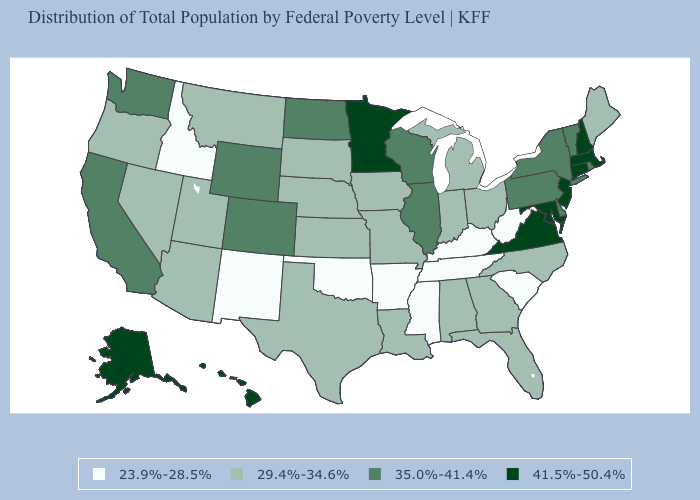Is the legend a continuous bar?
Be succinct. No. Does Massachusetts have a lower value than Arizona?
Concise answer only. No. How many symbols are there in the legend?
Give a very brief answer. 4. Name the states that have a value in the range 35.0%-41.4%?
Quick response, please. California, Colorado, Delaware, Illinois, New York, North Dakota, Pennsylvania, Rhode Island, Vermont, Washington, Wisconsin, Wyoming. What is the highest value in the USA?
Keep it brief. 41.5%-50.4%. Does Arkansas have the lowest value in the USA?
Short answer required. Yes. Does the first symbol in the legend represent the smallest category?
Write a very short answer. Yes. Does Alaska have the lowest value in the USA?
Concise answer only. No. Which states have the lowest value in the USA?
Be succinct. Arkansas, Idaho, Kentucky, Mississippi, New Mexico, Oklahoma, South Carolina, Tennessee, West Virginia. Does Virginia have the lowest value in the South?
Answer briefly. No. Is the legend a continuous bar?
Concise answer only. No. Among the states that border Nebraska , which have the highest value?
Concise answer only. Colorado, Wyoming. Name the states that have a value in the range 41.5%-50.4%?
Keep it brief. Alaska, Connecticut, Hawaii, Maryland, Massachusetts, Minnesota, New Hampshire, New Jersey, Virginia. Name the states that have a value in the range 29.4%-34.6%?
Quick response, please. Alabama, Arizona, Florida, Georgia, Indiana, Iowa, Kansas, Louisiana, Maine, Michigan, Missouri, Montana, Nebraska, Nevada, North Carolina, Ohio, Oregon, South Dakota, Texas, Utah. 